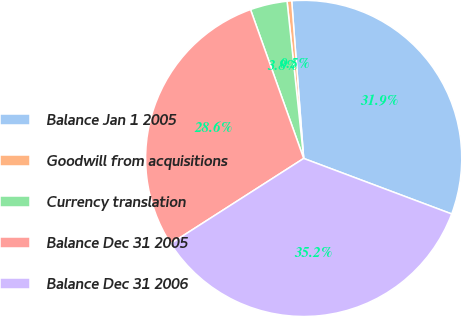<chart> <loc_0><loc_0><loc_500><loc_500><pie_chart><fcel>Balance Jan 1 2005<fcel>Goodwill from acquisitions<fcel>Currency translation<fcel>Balance Dec 31 2005<fcel>Balance Dec 31 2006<nl><fcel>31.92%<fcel>0.47%<fcel>3.78%<fcel>28.61%<fcel>35.22%<nl></chart> 